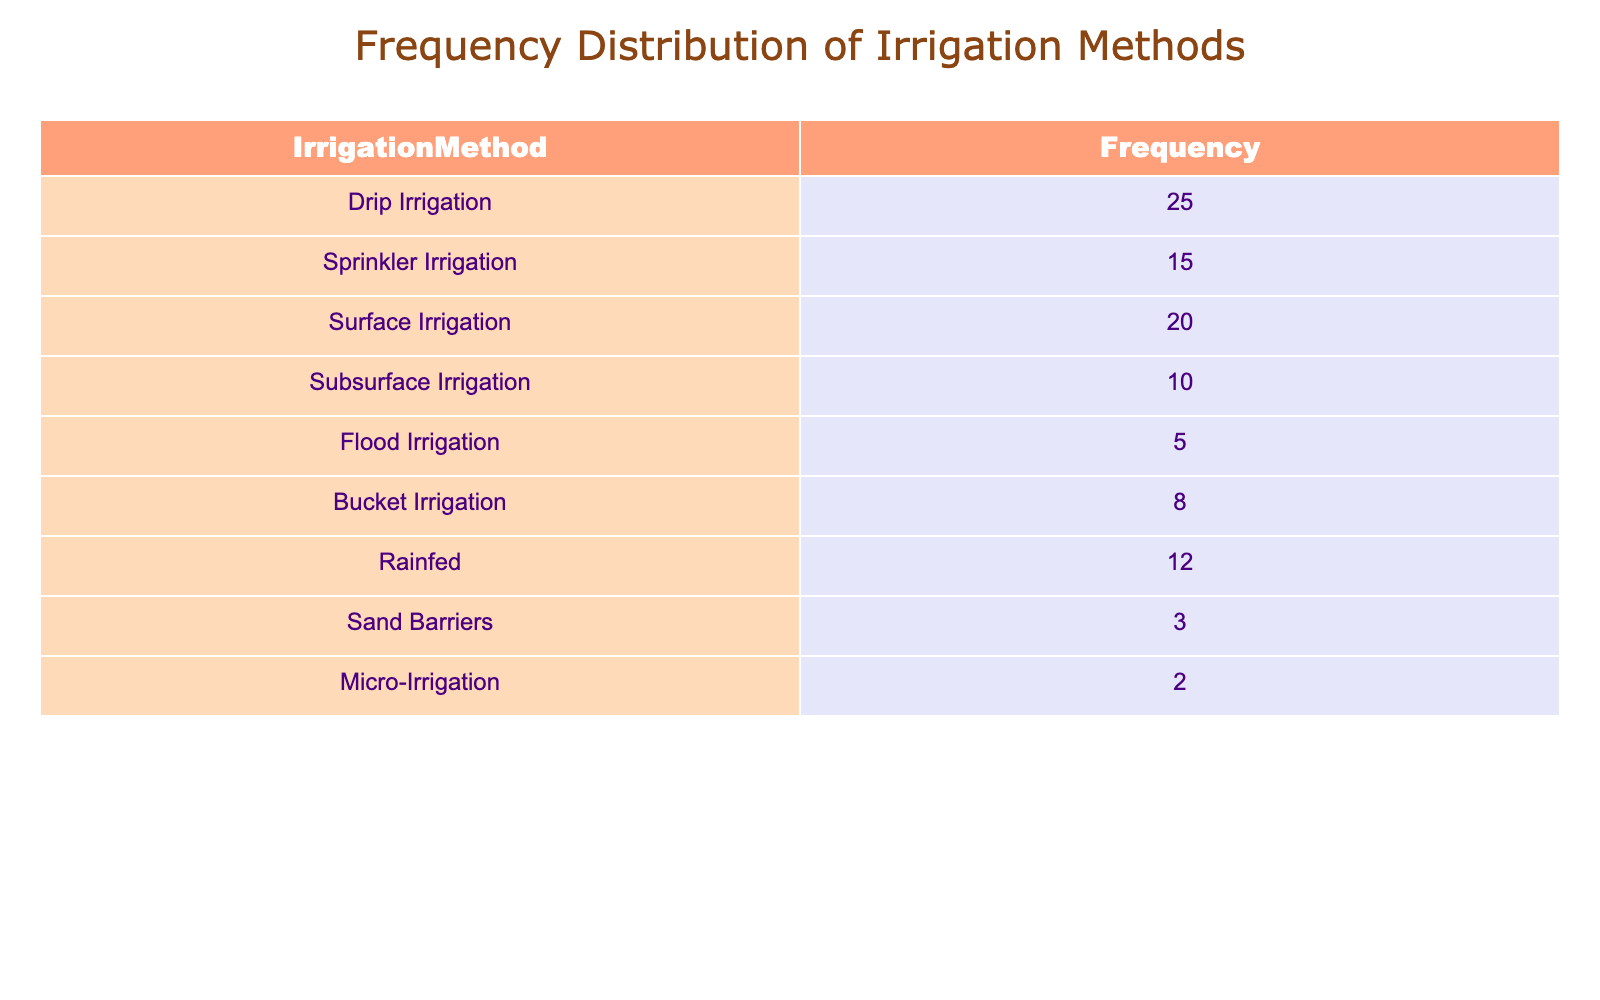What is the frequency of Drip Irrigation method used? The table shows that the frequency of the Drip Irrigation method is listed explicitly in the first row under the column 'Frequency' as 25.
Answer: 25 How many farmers use Sprinkler Irrigation? Referring to the table, the frequency for Sprinkler Irrigation is directly given as 15.
Answer: 15 What is the total frequency of traditional irrigation methods (Surface, Flood, and Bucket Irrigation)? By adding the frequencies of these methods: Surface (20) + Flood (5) + Bucket (8) gives a total of 20 + 5 + 8 = 33.
Answer: 33 Is Subsurface Irrigation the most used method among these farms? By comparing the frequencies, Subsurface Irrigation has a frequency of 10, while Drip (25) and Surface (20) have higher frequencies, so Subsurface Irrigation is not the most used method.
Answer: No What is the difference in frequency between Drip Irrigation and Rainfed? From the table, Drip Irrigation has a frequency of 25 and Rainfed has 12. The difference is 25 - 12 = 13.
Answer: 13 What is the combined frequency of all irrigation methods excluding Rainfed and Flood Irrigation? To find this, sum the frequencies of all methods and then subtract the frequencies of Rainfed (12) and Flood (5): Total = 25 + 15 + 20 + 10 + 8 + 3 + 2 = 93. Then, 93 - 12 - 5 = 76.
Answer: 76 Which irrigation method has the least frequency? In the table, Sand Barriers and Micro-Irrigation have the lowest frequencies of 3 and 2, respectively. Micro-Irrigation is the least, since it has the lowest count.
Answer: Micro-Irrigation If a farmer decides to switch from Flood Irrigation to Drip Irrigation, how many more farms would be using Drip Irrigation? Flood Irrigation has a frequency of 5 and Drip Irrigation has 25. The difference is 25 - 5 = 20, meaning 20 more farms would be using Drip after the switch.
Answer: 20 What is the total number of farms represented in this table? To find the total number of farms, add up the frequencies of all irrigation methods: 25 + 15 + 20 + 10 + 5 + 8 + 12 + 3 + 2 = 100.
Answer: 100 